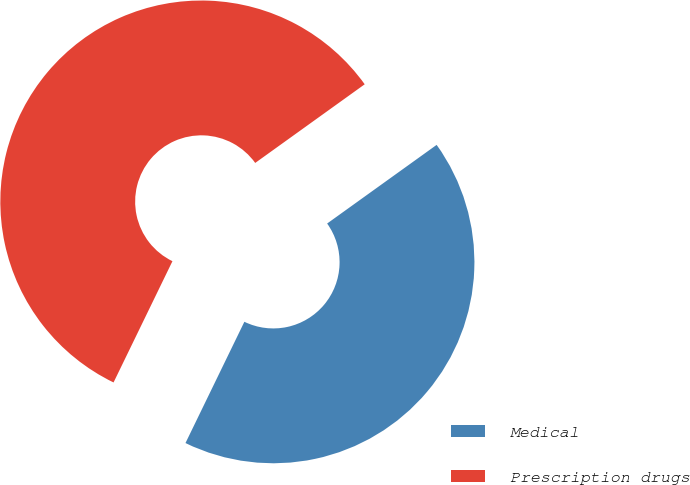Convert chart. <chart><loc_0><loc_0><loc_500><loc_500><pie_chart><fcel>Medical<fcel>Prescription drugs<nl><fcel>42.11%<fcel>57.89%<nl></chart> 